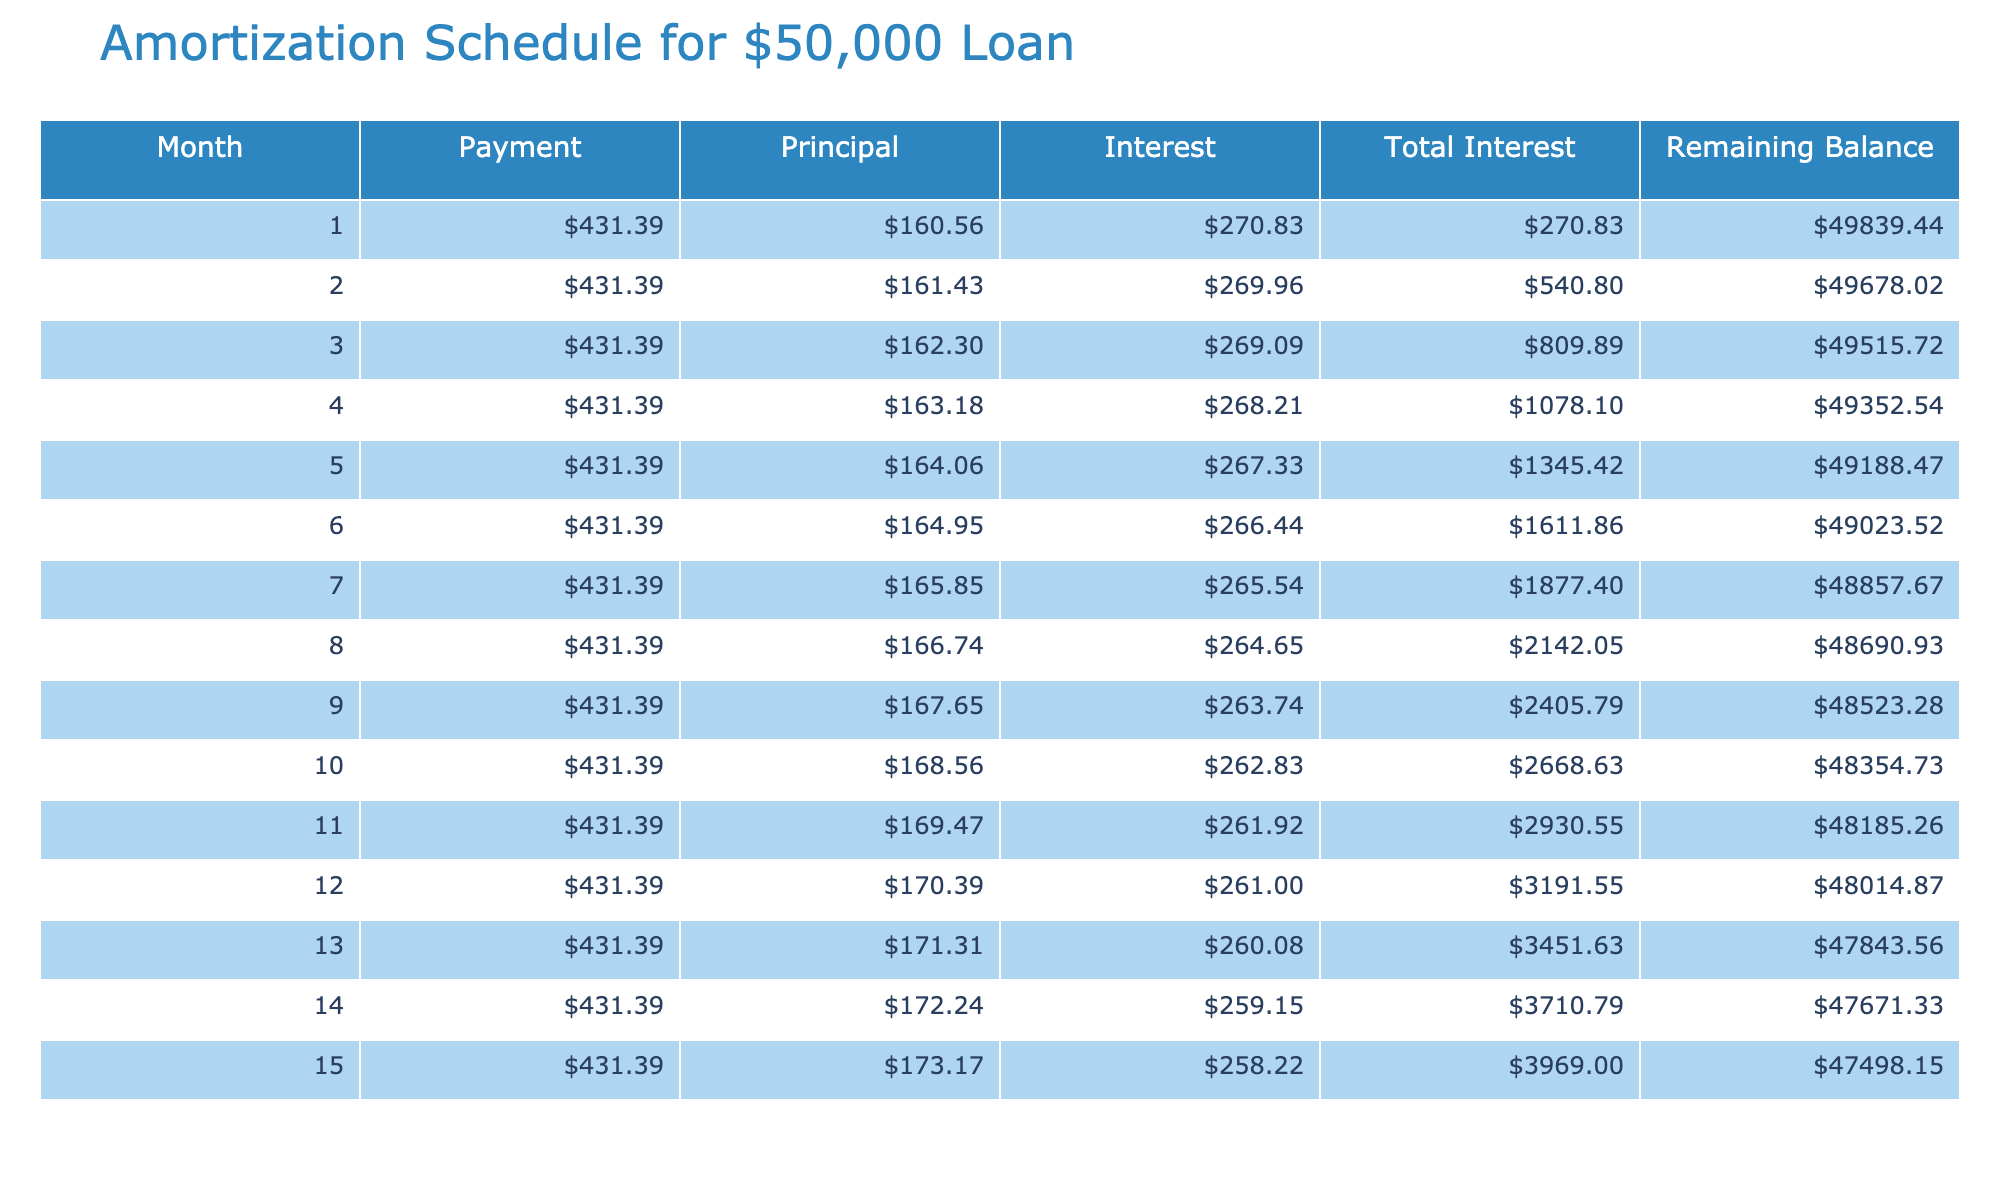What is the total amount of interest paid over the loan term? The table indicates that the total interest paid is $17,583.21 as seen in the "Total Interest Paid" column.
Answer: $17,583.21 What is the remaining balance after the first month? According to the "Remaining Balance" column for the first month, the amount shows $49,618.61 after making the first payment.
Answer: $49,618.61 How much is the monthly payment on this loan? The "Monthly Payment" column states that the payment is $431.39 per month.
Answer: $431.39 Is the total payment greater than $60,000? The "Total Payment" column shows $67,583.21, which is indeed greater than $60,000.
Answer: Yes What amount of interest is paid in the last month? In the last month (15th month), the "Interest" column indicates that $18.59 is paid.
Answer: $18.59 What is the total principal paid over the entire loan term? The total payment is $67,583.21, and the total interest paid is $17,583.21. Therefore, the total principal is calculated by subtracting total interest from total payment: $67,583.21 - $17,583.21 = $50,000.
Answer: $50,000 How much is paid towards the principal in the 5th month? Referring to the "Principal" column for the 5th month, the amount indicates $425.71 is applied to the principal.
Answer: $425.71 What is the average monthly interest paid during the loan term? To find the average monthly interest, divide the total interest paid ($17,583.21) by the loan term in months (15): $17,583.21 / 15 = $1,172.21.
Answer: $1,172.21 How much total payment is made by the midpoint of the loan term (after 7 months)? The total payment made after 7 months calculates to be $431.39 multiplied by 7, resulting in $3,019.73.
Answer: $3,019.73 